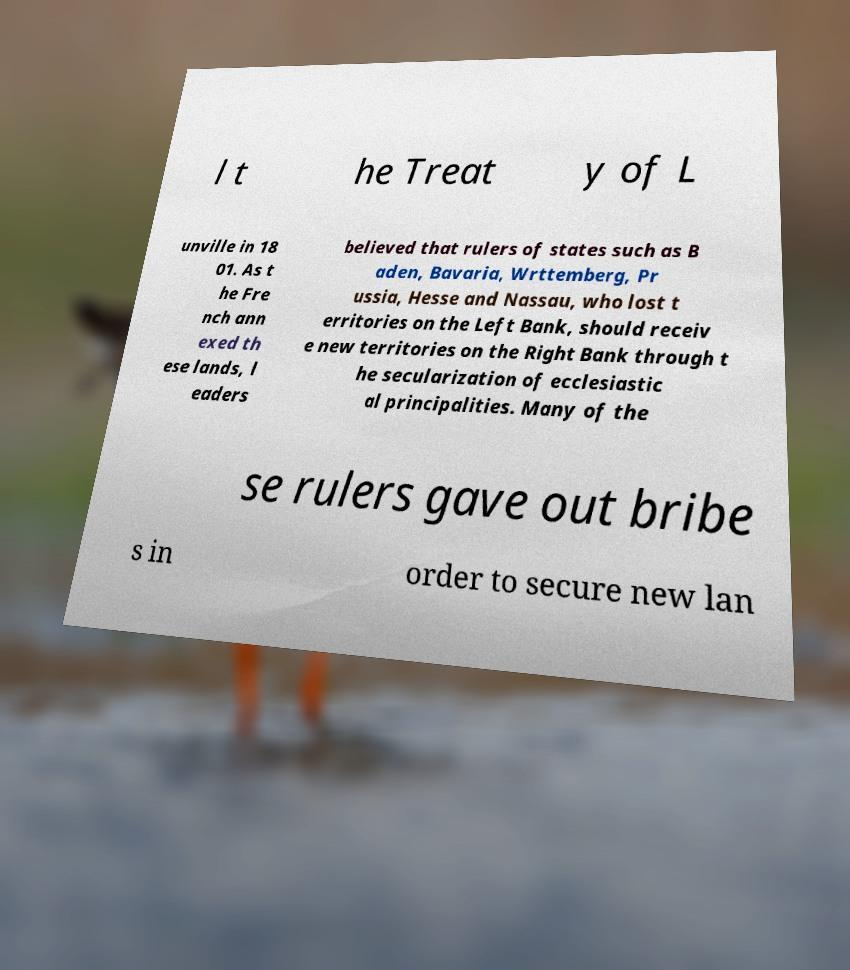There's text embedded in this image that I need extracted. Can you transcribe it verbatim? l t he Treat y of L unville in 18 01. As t he Fre nch ann exed th ese lands, l eaders believed that rulers of states such as B aden, Bavaria, Wrttemberg, Pr ussia, Hesse and Nassau, who lost t erritories on the Left Bank, should receiv e new territories on the Right Bank through t he secularization of ecclesiastic al principalities. Many of the se rulers gave out bribe s in order to secure new lan 